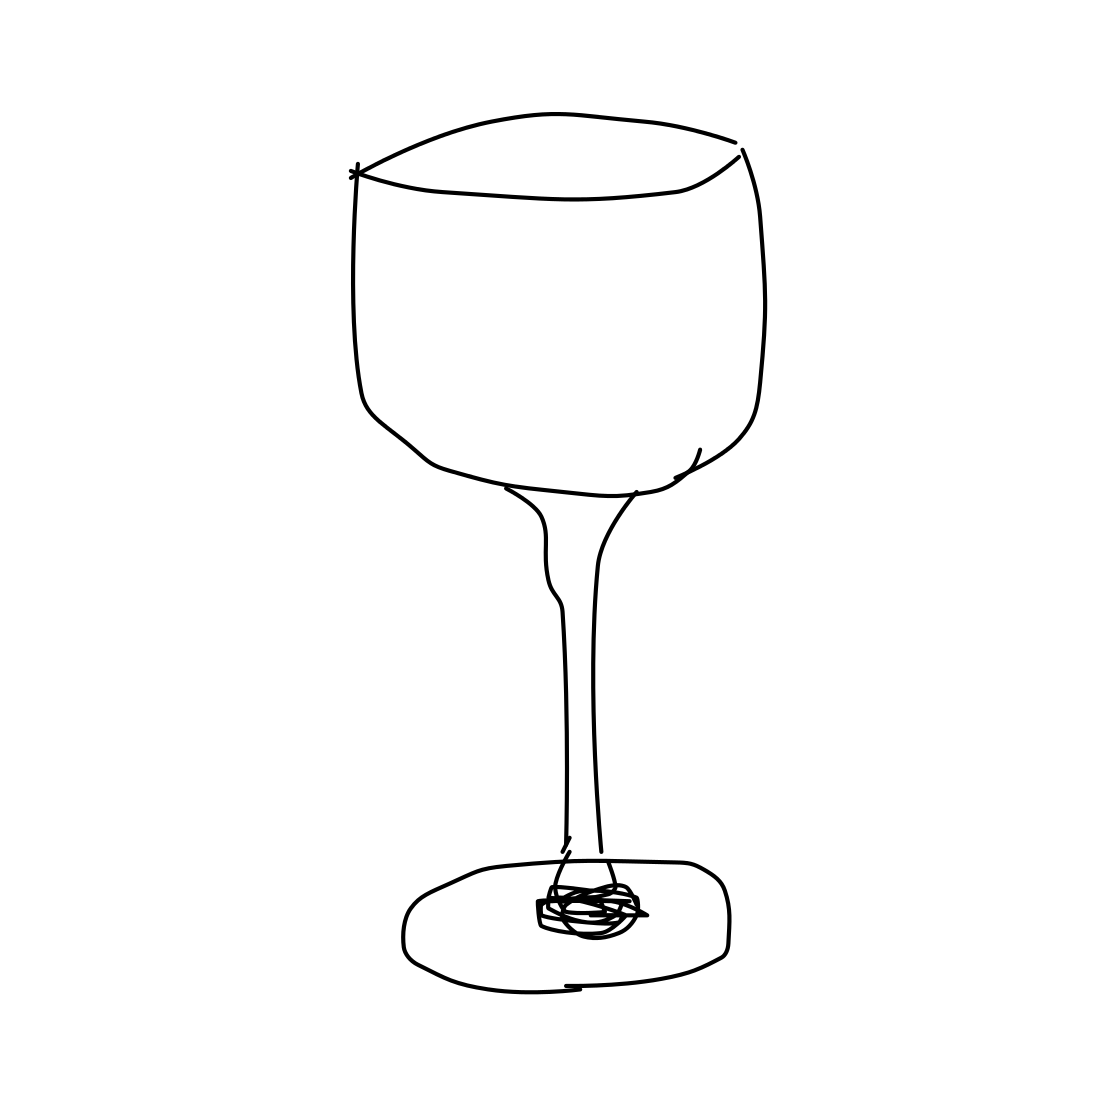Is this a wineglass in the image? Yes 